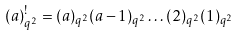<formula> <loc_0><loc_0><loc_500><loc_500>( a ) _ { q ^ { 2 } } ^ { ! } = ( a ) _ { q ^ { 2 } } ( a - 1 ) _ { q ^ { 2 } } \dots ( 2 ) _ { q ^ { 2 } } ( 1 ) _ { q ^ { 2 } }</formula> 